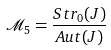<formula> <loc_0><loc_0><loc_500><loc_500>\mathcal { M } _ { 5 } = \frac { S t r _ { 0 } ( J ) } { A u t ( J ) }</formula> 